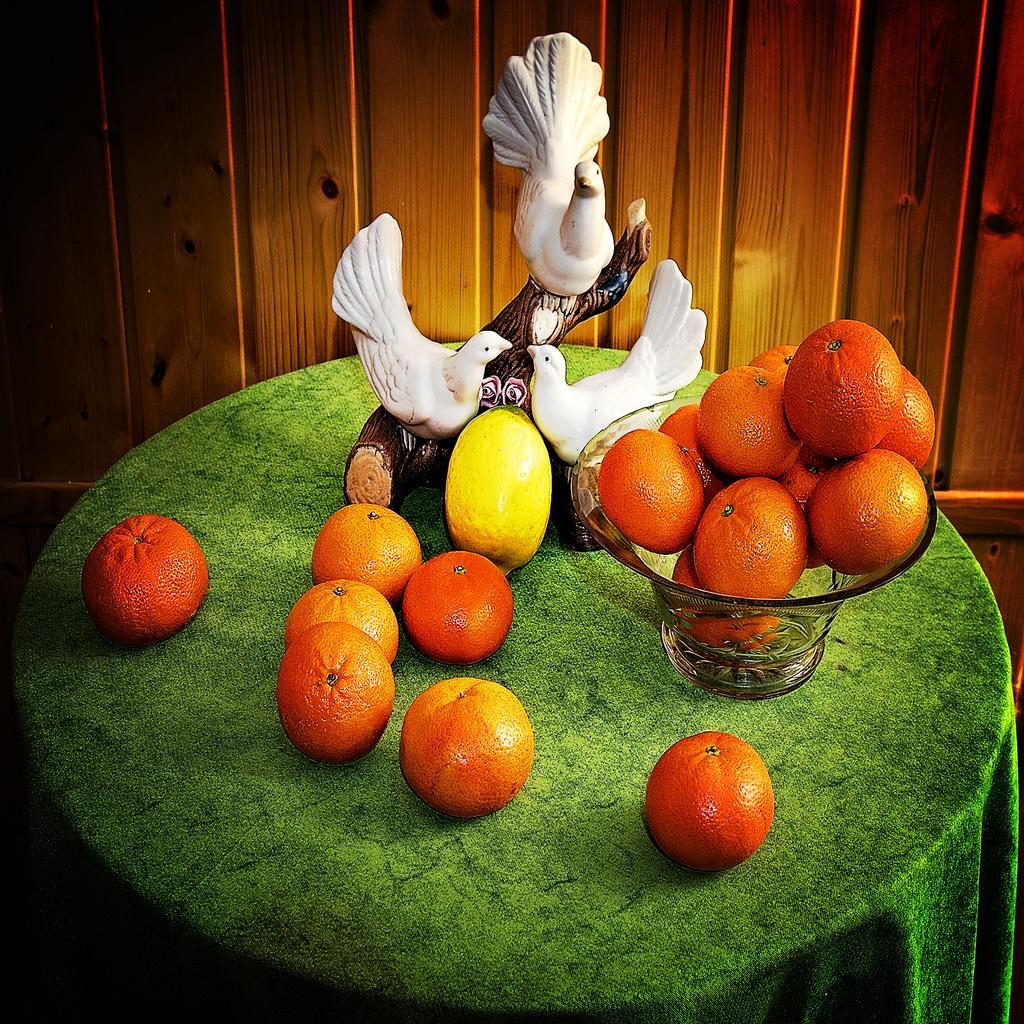Could you give a brief overview of what you see in this image? In this image we can see some fruits which are in a glass bowl and some are on table, there is a show piece of birds also on table on which there is green color cloth and in the background of the image there is a wooden surface. 